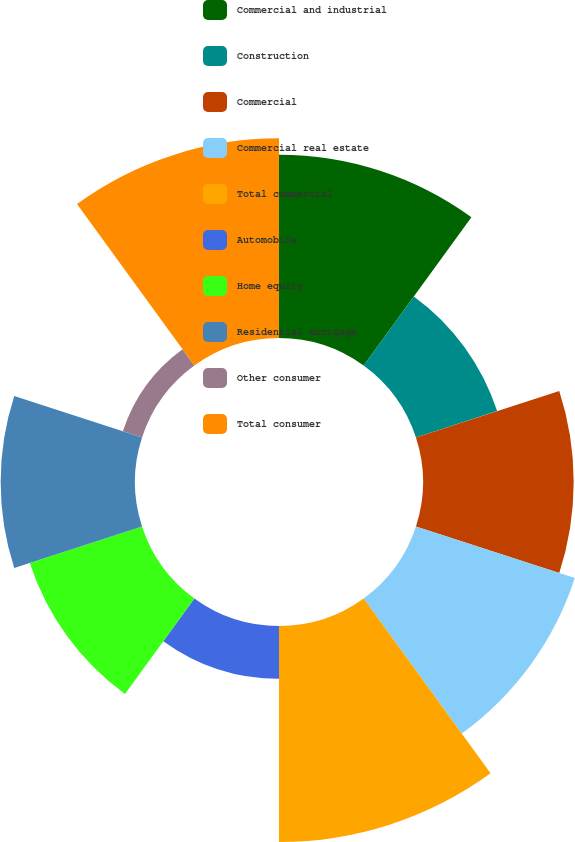Convert chart. <chart><loc_0><loc_0><loc_500><loc_500><pie_chart><fcel>Commercial and industrial<fcel>Construction<fcel>Commercial<fcel>Commercial real estate<fcel>Total commercial<fcel>Automobile<fcel>Home equity<fcel>Residential mortgage<fcel>Other consumer<fcel>Total consumer<nl><fcel>13.81%<fcel>6.43%<fcel>11.35%<fcel>12.58%<fcel>16.27%<fcel>3.98%<fcel>8.89%<fcel>10.12%<fcel>1.52%<fcel>15.04%<nl></chart> 